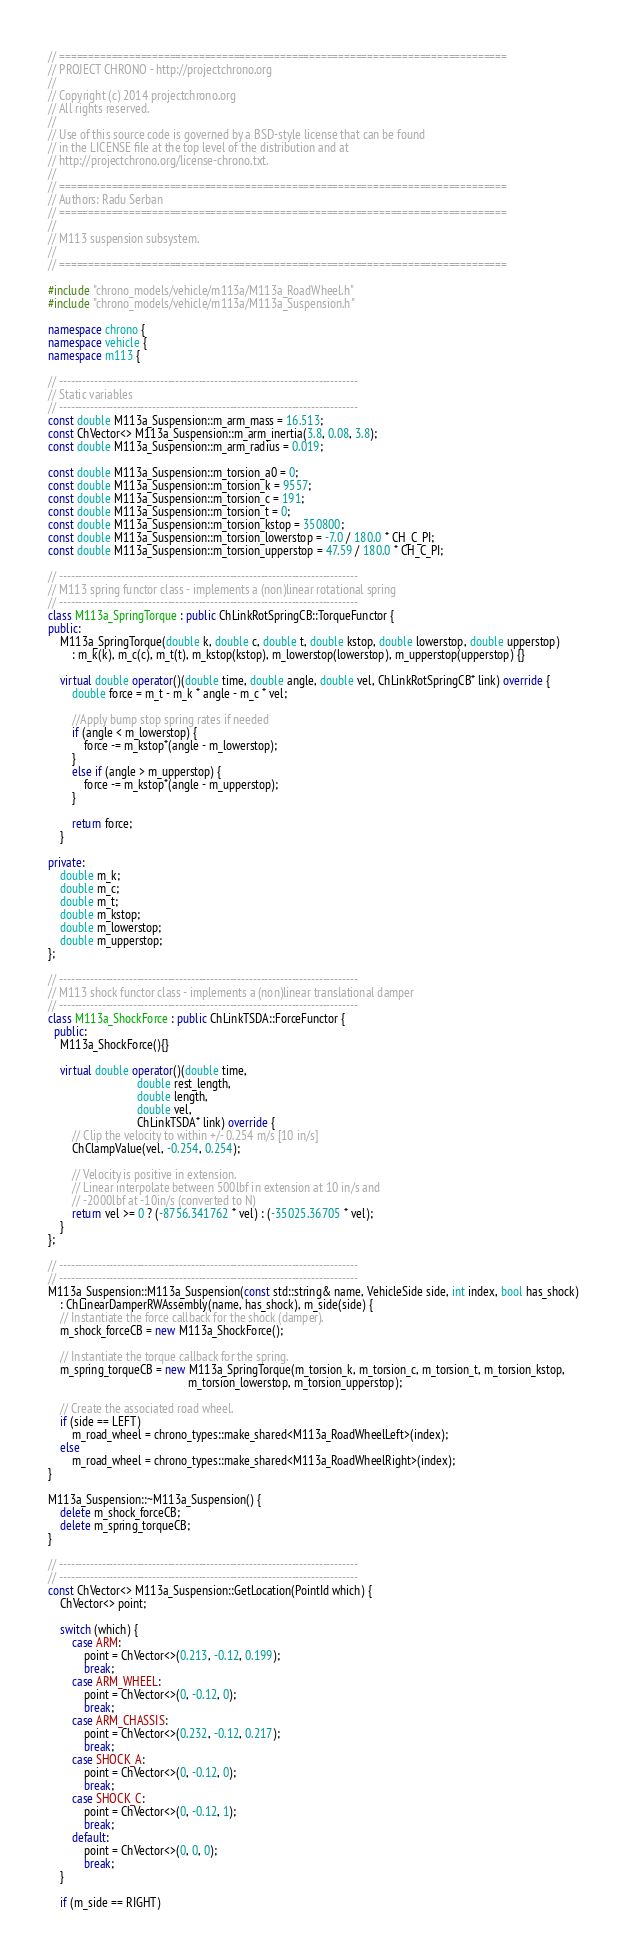<code> <loc_0><loc_0><loc_500><loc_500><_C++_>// =============================================================================
// PROJECT CHRONO - http://projectchrono.org
//
// Copyright (c) 2014 projectchrono.org
// All rights reserved.
//
// Use of this source code is governed by a BSD-style license that can be found
// in the LICENSE file at the top level of the distribution and at
// http://projectchrono.org/license-chrono.txt.
//
// =============================================================================
// Authors: Radu Serban
// =============================================================================
//
// M113 suspension subsystem.
//
// =============================================================================

#include "chrono_models/vehicle/m113a/M113a_RoadWheel.h"
#include "chrono_models/vehicle/m113a/M113a_Suspension.h"

namespace chrono {
namespace vehicle {
namespace m113 {

// -----------------------------------------------------------------------------
// Static variables
// -----------------------------------------------------------------------------
const double M113a_Suspension::m_arm_mass = 16.513;
const ChVector<> M113a_Suspension::m_arm_inertia(3.8, 0.08, 3.8);
const double M113a_Suspension::m_arm_radius = 0.019;

const double M113a_Suspension::m_torsion_a0 = 0;
const double M113a_Suspension::m_torsion_k = 9557;
const double M113a_Suspension::m_torsion_c = 191;
const double M113a_Suspension::m_torsion_t = 0;
const double M113a_Suspension::m_torsion_kstop = 350800;
const double M113a_Suspension::m_torsion_lowerstop = -7.0 / 180.0 * CH_C_PI;
const double M113a_Suspension::m_torsion_upperstop = 47.59 / 180.0 * CH_C_PI;

// -----------------------------------------------------------------------------
// M113 spring functor class - implements a (non)linear rotational spring
// -----------------------------------------------------------------------------
class M113a_SpringTorque : public ChLinkRotSpringCB::TorqueFunctor {
public:
    M113a_SpringTorque(double k, double c, double t, double kstop, double lowerstop, double upperstop) 
        : m_k(k), m_c(c), m_t(t), m_kstop(kstop), m_lowerstop(lowerstop), m_upperstop(upperstop) {}

    virtual double operator()(double time, double angle, double vel, ChLinkRotSpringCB* link) override {
        double force = m_t - m_k * angle - m_c * vel;

        //Apply bump stop spring rates if needed
        if (angle < m_lowerstop) {
            force -= m_kstop*(angle - m_lowerstop);
        }
        else if (angle > m_upperstop) {
            force -= m_kstop*(angle - m_upperstop);
        }

        return force;
    }

private:
    double m_k;
    double m_c;
    double m_t;
    double m_kstop;
    double m_lowerstop;
    double m_upperstop;
};

// -----------------------------------------------------------------------------
// M113 shock functor class - implements a (non)linear translational damper
// -----------------------------------------------------------------------------
class M113a_ShockForce : public ChLinkTSDA::ForceFunctor {
  public:
    M113a_ShockForce(){}

    virtual double operator()(double time,
                              double rest_length,
                              double length,
                              double vel,
                              ChLinkTSDA* link) override {
        // Clip the velocity to within +/- 0.254 m/s [10 in/s]
        ChClampValue(vel, -0.254, 0.254);

        // Velocity is positive in extension.
        // Linear interpolate between 500lbf in extension at 10 in/s and
        // -2000lbf at -10in/s (converted to N)
        return vel >= 0 ? (-8756.341762 * vel) : (-35025.36705 * vel);
    }
};

// -----------------------------------------------------------------------------
// -----------------------------------------------------------------------------
M113a_Suspension::M113a_Suspension(const std::string& name, VehicleSide side, int index, bool has_shock)
    : ChLinearDamperRWAssembly(name, has_shock), m_side(side) {
    // Instantiate the force callback for the shock (damper).
    m_shock_forceCB = new M113a_ShockForce();

    // Instantiate the torque callback for the spring.
    m_spring_torqueCB = new M113a_SpringTorque(m_torsion_k, m_torsion_c, m_torsion_t, m_torsion_kstop,
                                               m_torsion_lowerstop, m_torsion_upperstop);

    // Create the associated road wheel.
    if (side == LEFT)
        m_road_wheel = chrono_types::make_shared<M113a_RoadWheelLeft>(index);
    else
        m_road_wheel = chrono_types::make_shared<M113a_RoadWheelRight>(index);
}

M113a_Suspension::~M113a_Suspension() {
    delete m_shock_forceCB;
    delete m_spring_torqueCB;
}

// -----------------------------------------------------------------------------
// -----------------------------------------------------------------------------
const ChVector<> M113a_Suspension::GetLocation(PointId which) {
    ChVector<> point;

    switch (which) {
        case ARM:
            point = ChVector<>(0.213, -0.12, 0.199);
            break;
        case ARM_WHEEL:
            point = ChVector<>(0, -0.12, 0);
            break;
        case ARM_CHASSIS:
            point = ChVector<>(0.232, -0.12, 0.217);
            break;
        case SHOCK_A:
            point = ChVector<>(0, -0.12, 0);
            break;
        case SHOCK_C:
            point = ChVector<>(0, -0.12, 1);
            break;
        default:
            point = ChVector<>(0, 0, 0);
            break;
    }

    if (m_side == RIGHT)</code> 